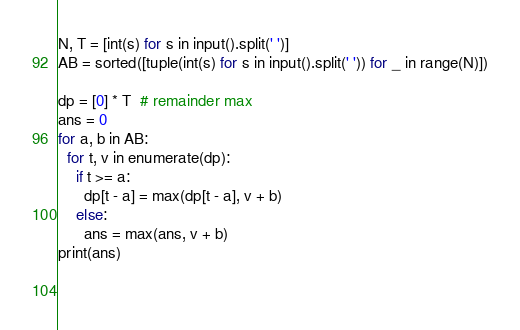Convert code to text. <code><loc_0><loc_0><loc_500><loc_500><_Python_>N, T = [int(s) for s in input().split(' ')]
AB = sorted([tuple(int(s) for s in input().split(' ')) for _ in range(N)])

dp = [0] * T  # remainder max
ans = 0
for a, b in AB:
  for t, v in enumerate(dp):
    if t >= a:
      dp[t - a] = max(dp[t - a], v + b)
    else:
      ans = max(ans, v + b)
print(ans)
  
  </code> 